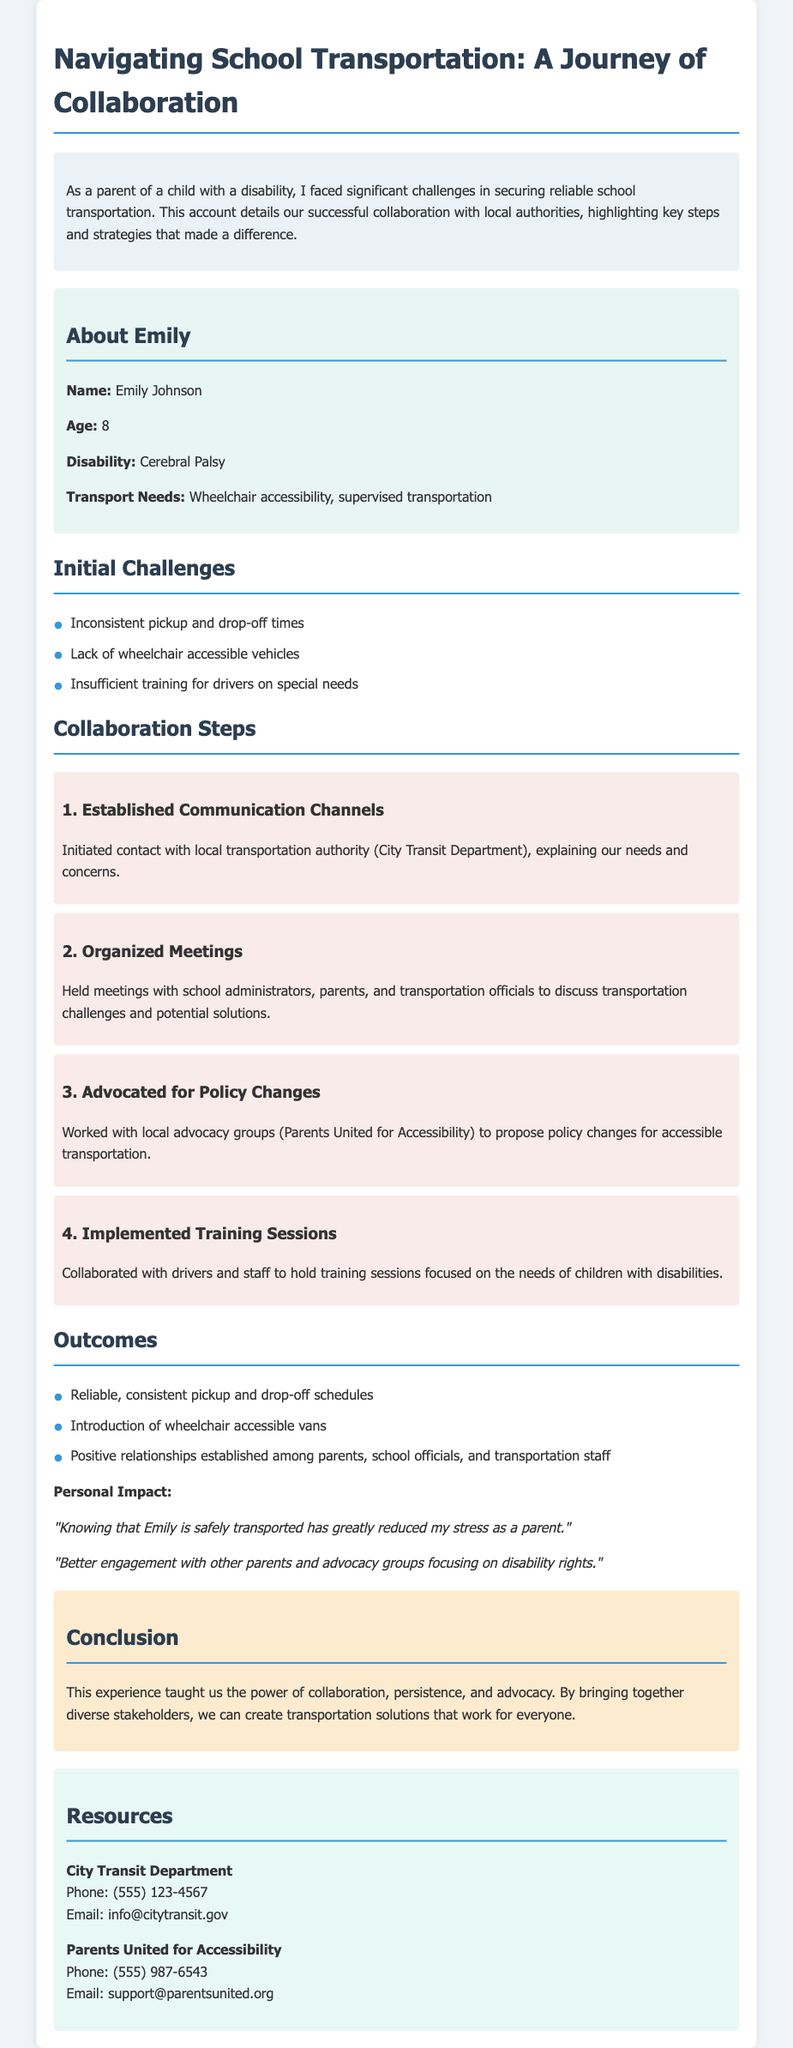What is the name of the child discussed in the document? The child's name is mentioned in the profile section of the document.
Answer: Emily Johnson What disability does Emily have? The document specifies Emily's disability in the profile section.
Answer: Cerebral Palsy How old is Emily? Emily's age is clearly stated in the profile section of the document.
Answer: 8 What is one initial challenge mentioned? The document lists challenges in the challenges section that faced the family regarding transportation.
Answer: Inconsistent pickup and drop-off times Who did the parents collaborate with for policy changes? The document names the advocacy group involved in the policy changes.
Answer: Parents United for Accessibility What type of vehicle was introduced as an outcome? The outcomes section of the document highlights new transport features.
Answer: Wheelchair accessible vans What positive effect did consistent transportation have on the parent? The personal impact section includes reflections from the parent regarding transportation.
Answer: Reduced stress What was the conclusion about the collaboration experience? The conclusion summarizes the overall learning from the experience.
Answer: Power of collaboration, persistence, and advocacy What type of information is provided in the resources section? The resources section provides contact details for organizations related to transportation and advocacy.
Answer: Contact details 